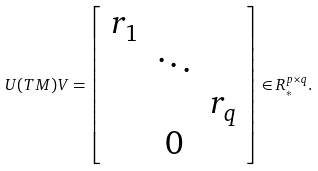Convert formula to latex. <formula><loc_0><loc_0><loc_500><loc_500>U ( T M ) V = \left [ \begin{array} { c c c } r _ { 1 } & & \\ & \ddots & \\ & & r _ { q } \\ & 0 & \end{array} \right ] \in R _ { * } ^ { p \times q } .</formula> 